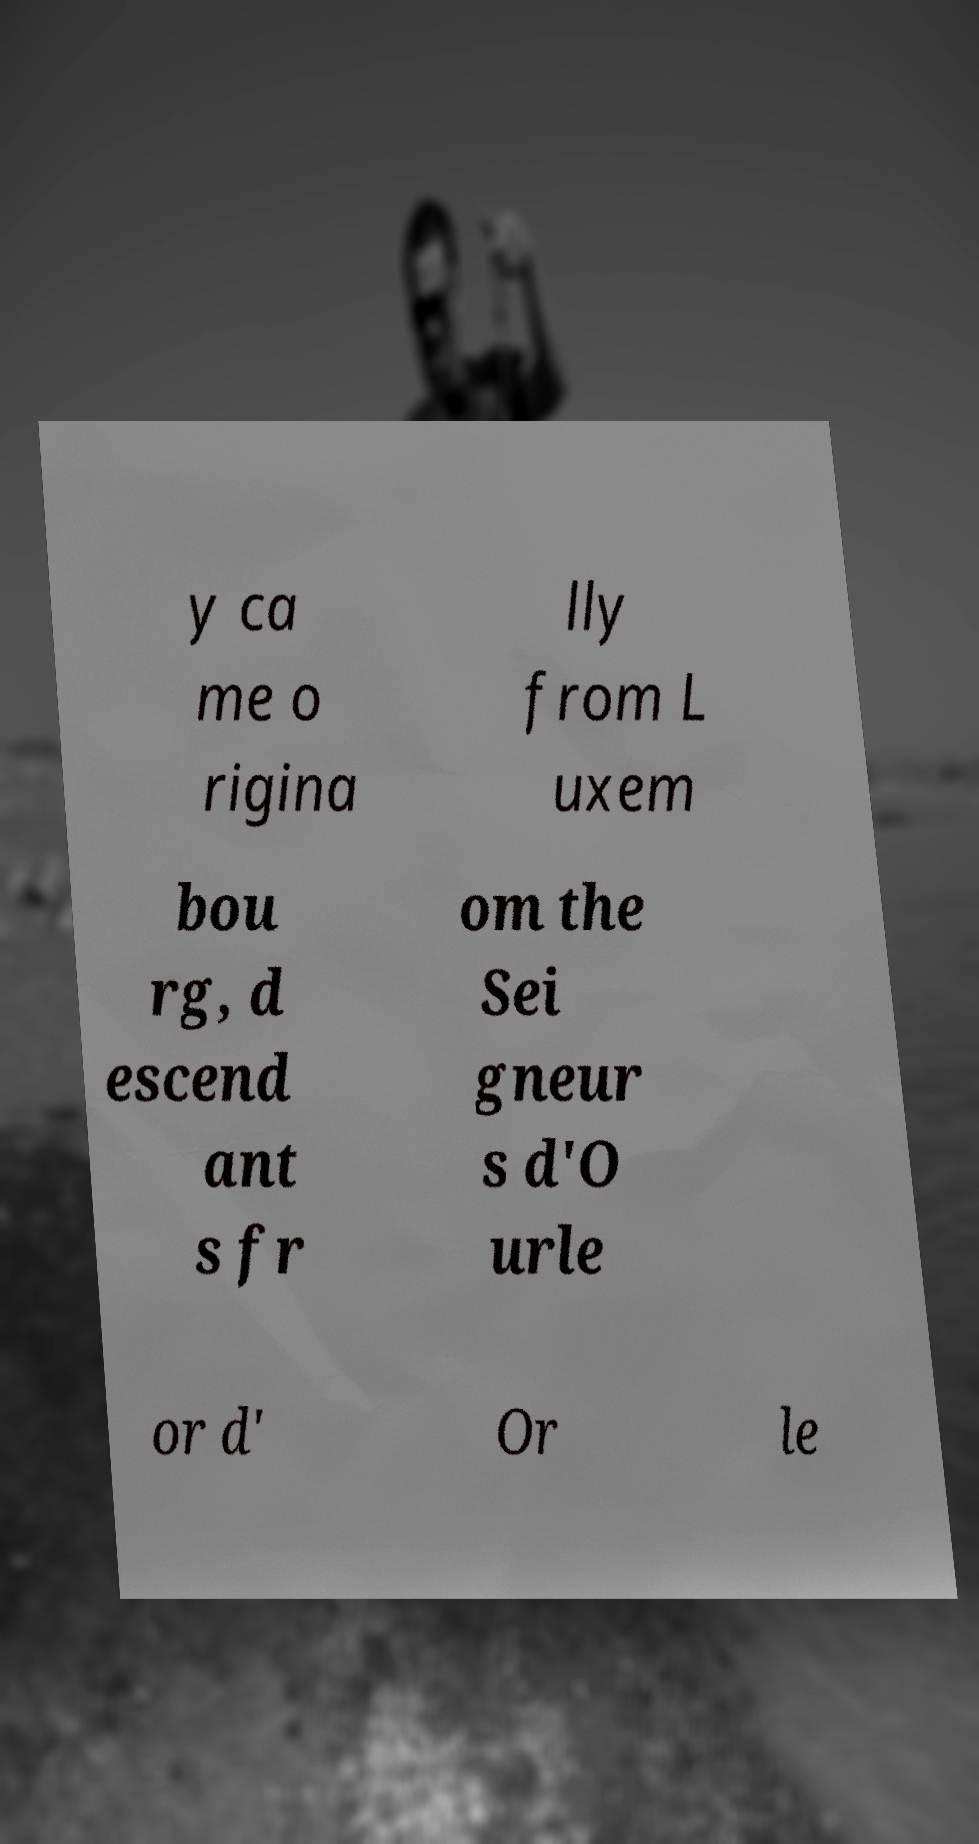I need the written content from this picture converted into text. Can you do that? y ca me o rigina lly from L uxem bou rg, d escend ant s fr om the Sei gneur s d'O urle or d' Or le 